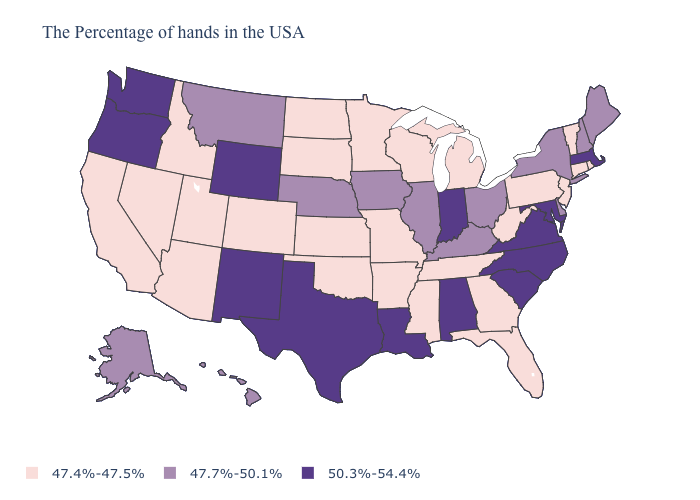Name the states that have a value in the range 47.4%-47.5%?
Give a very brief answer. Rhode Island, Vermont, Connecticut, New Jersey, Pennsylvania, West Virginia, Florida, Georgia, Michigan, Tennessee, Wisconsin, Mississippi, Missouri, Arkansas, Minnesota, Kansas, Oklahoma, South Dakota, North Dakota, Colorado, Utah, Arizona, Idaho, Nevada, California. Among the states that border Delaware , which have the lowest value?
Give a very brief answer. New Jersey, Pennsylvania. Name the states that have a value in the range 47.7%-50.1%?
Write a very short answer. Maine, New Hampshire, New York, Delaware, Ohio, Kentucky, Illinois, Iowa, Nebraska, Montana, Alaska, Hawaii. Which states have the lowest value in the USA?
Answer briefly. Rhode Island, Vermont, Connecticut, New Jersey, Pennsylvania, West Virginia, Florida, Georgia, Michigan, Tennessee, Wisconsin, Mississippi, Missouri, Arkansas, Minnesota, Kansas, Oklahoma, South Dakota, North Dakota, Colorado, Utah, Arizona, Idaho, Nevada, California. How many symbols are there in the legend?
Answer briefly. 3. Does Wisconsin have the lowest value in the USA?
Answer briefly. Yes. What is the lowest value in the USA?
Answer briefly. 47.4%-47.5%. Among the states that border Montana , does Idaho have the highest value?
Be succinct. No. How many symbols are there in the legend?
Be succinct. 3. Does Vermont have the same value as Maine?
Keep it brief. No. Does the map have missing data?
Give a very brief answer. No. What is the value of Georgia?
Short answer required. 47.4%-47.5%. Name the states that have a value in the range 47.4%-47.5%?
Write a very short answer. Rhode Island, Vermont, Connecticut, New Jersey, Pennsylvania, West Virginia, Florida, Georgia, Michigan, Tennessee, Wisconsin, Mississippi, Missouri, Arkansas, Minnesota, Kansas, Oklahoma, South Dakota, North Dakota, Colorado, Utah, Arizona, Idaho, Nevada, California. Name the states that have a value in the range 47.7%-50.1%?
Keep it brief. Maine, New Hampshire, New York, Delaware, Ohio, Kentucky, Illinois, Iowa, Nebraska, Montana, Alaska, Hawaii. Name the states that have a value in the range 47.4%-47.5%?
Write a very short answer. Rhode Island, Vermont, Connecticut, New Jersey, Pennsylvania, West Virginia, Florida, Georgia, Michigan, Tennessee, Wisconsin, Mississippi, Missouri, Arkansas, Minnesota, Kansas, Oklahoma, South Dakota, North Dakota, Colorado, Utah, Arizona, Idaho, Nevada, California. 